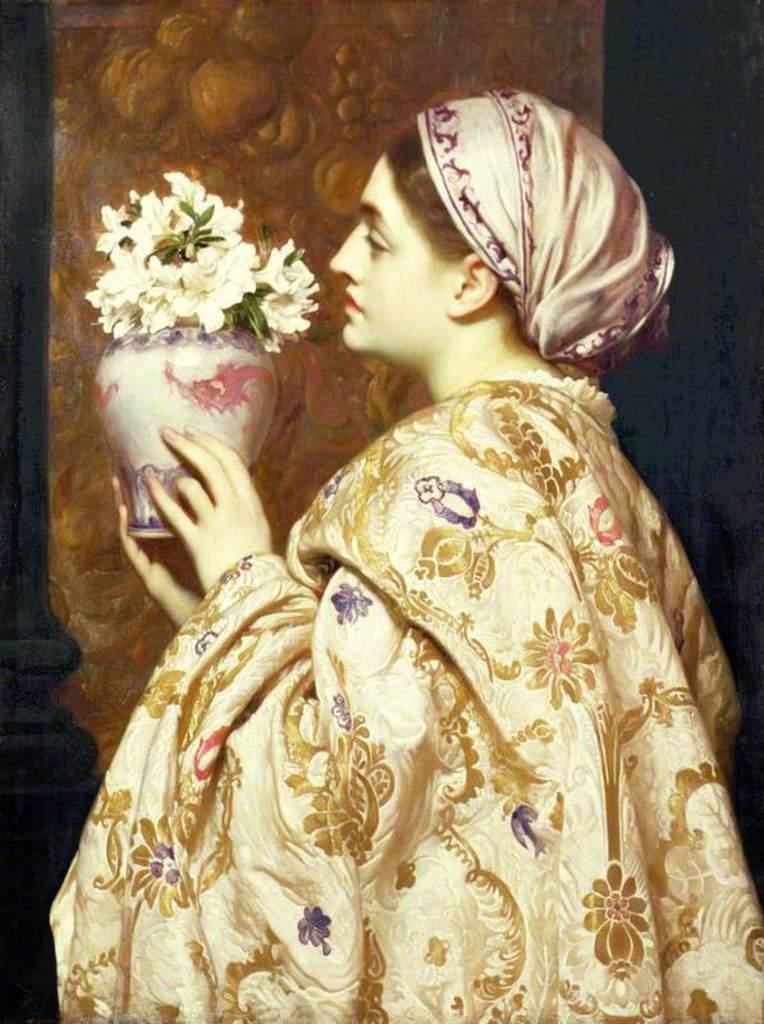Can you describe this image briefly? It is the sculpture of a woman,she is holding a flower vase in her hand. 